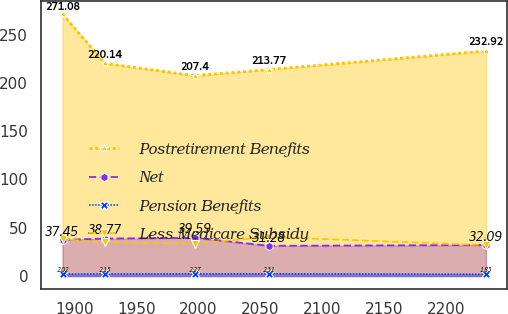Convert chart. <chart><loc_0><loc_0><loc_500><loc_500><line_chart><ecel><fcel>Postretirement Benefits<fcel>Net<fcel>Pension Benefits<fcel>Less Medicare Subsidy<nl><fcel>1890.36<fcel>271.08<fcel>37.45<fcel>2.02<fcel>38.14<nl><fcel>1924.49<fcel>220.14<fcel>38.77<fcel>2.15<fcel>34.95<nl><fcel>1997.06<fcel>207.4<fcel>39.59<fcel>2.27<fcel>33.57<nl><fcel>2056.97<fcel>213.77<fcel>31.28<fcel>2.31<fcel>40.4<nl><fcel>2231.65<fcel>232.92<fcel>32.09<fcel>1.83<fcel>31.99<nl></chart> 